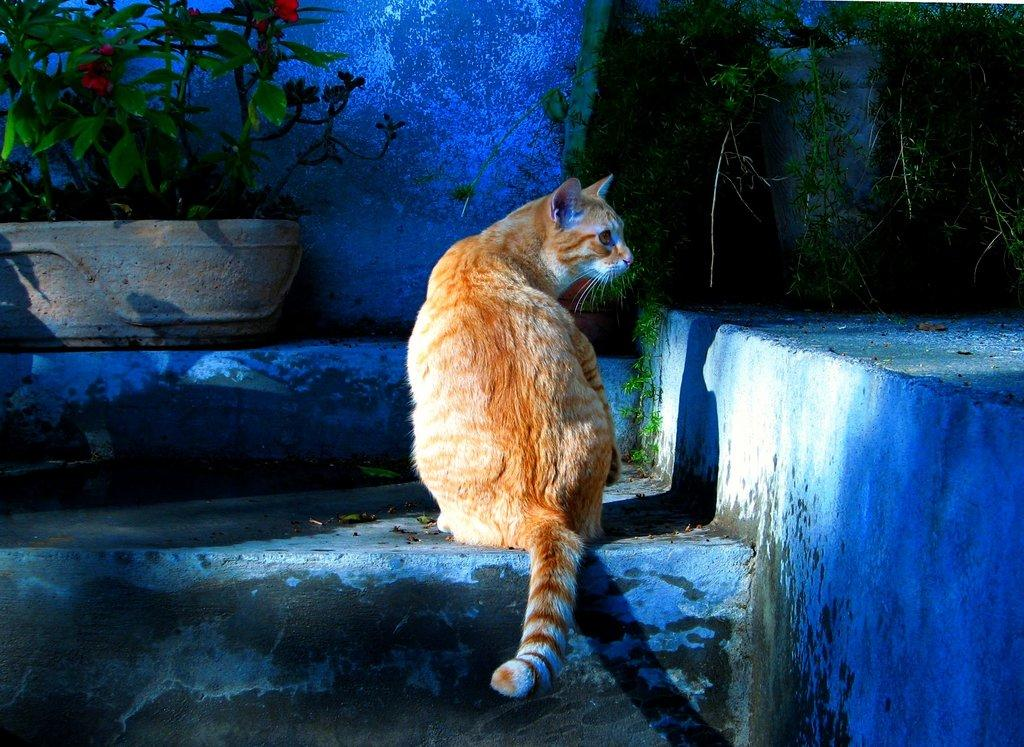What animal can be seen in the image? There is a cat in the image. In which direction is the cat looking? The cat is looking to the right side of the image. What is located in front of the cat? There are plants and a wall in front of the cat. What month is it in the image? The month cannot be determined from the image, as it does not contain any information about the time of year. 